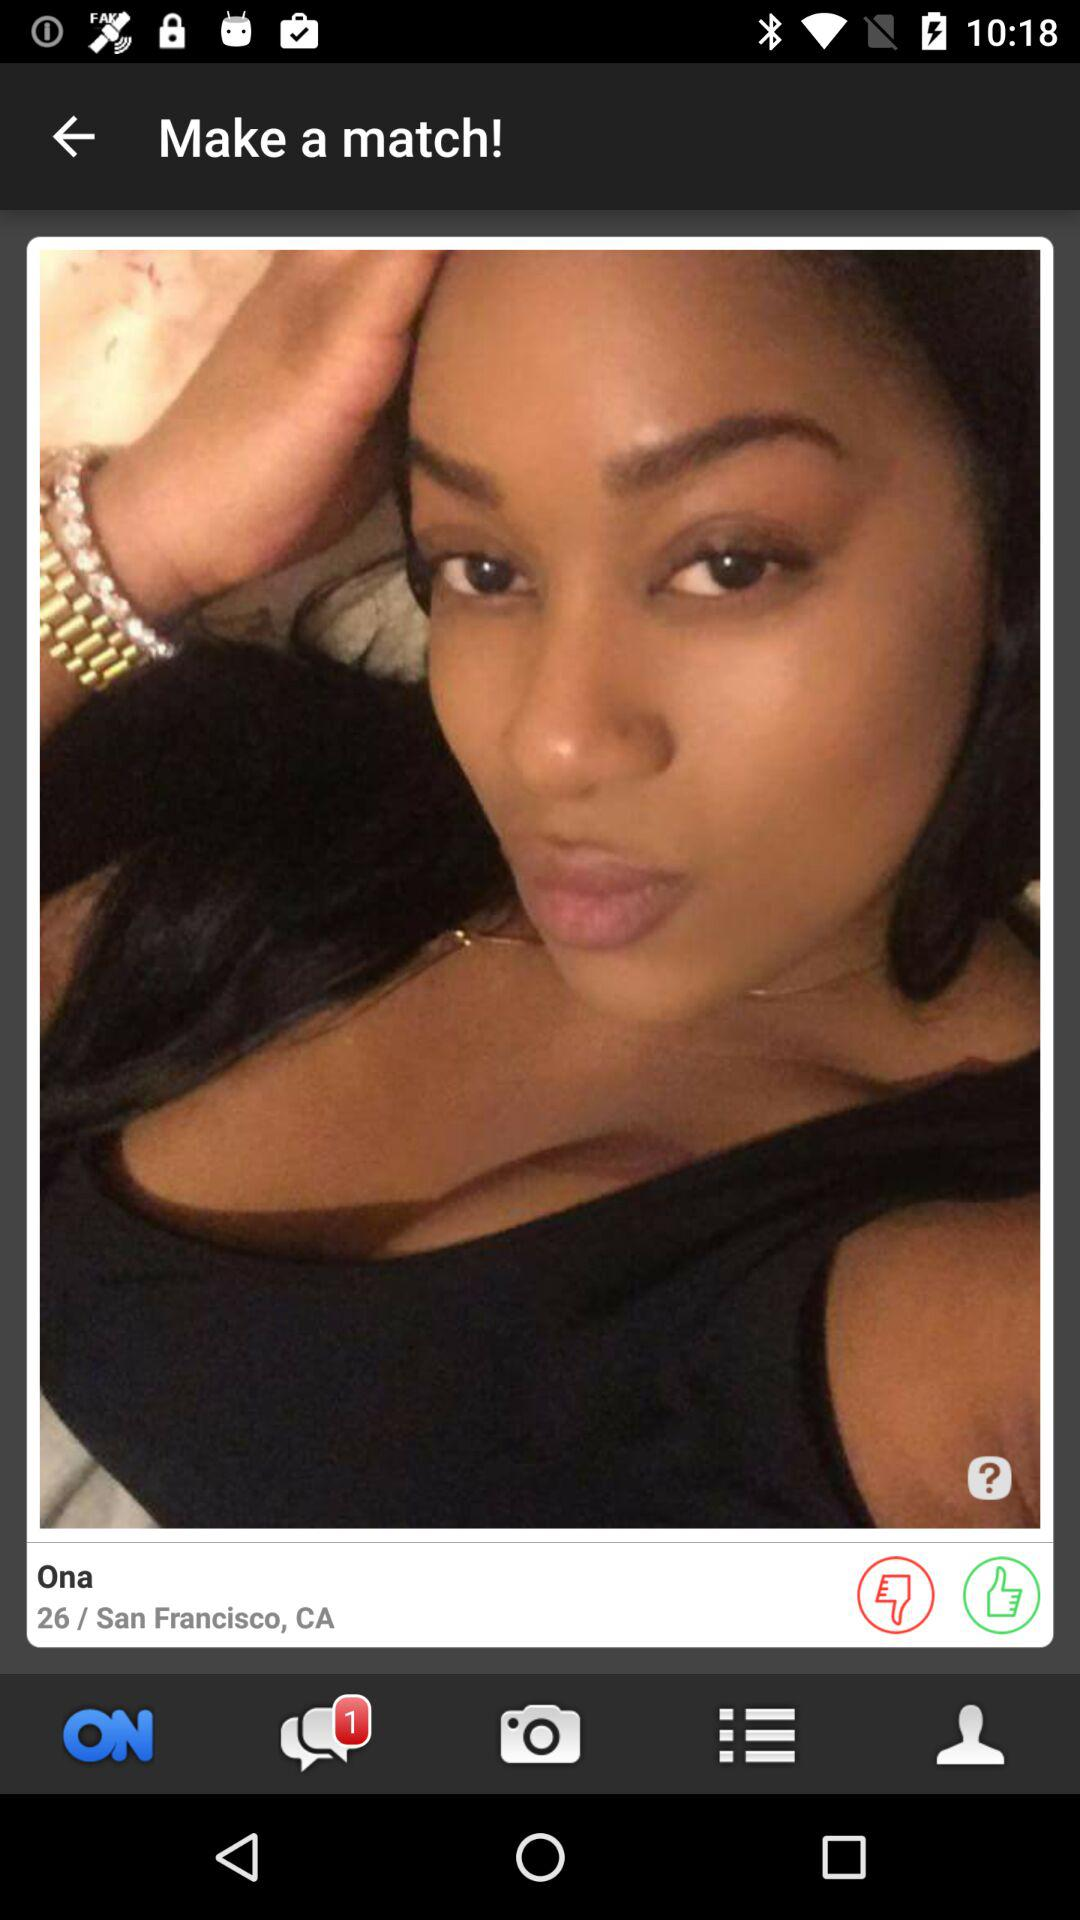What is the name of the city from where the user belong? The name of the city is San Francisco. 